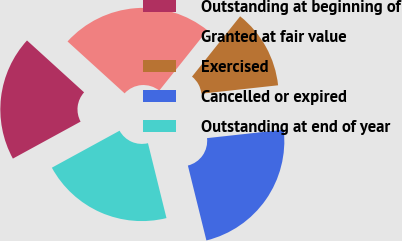Convert chart. <chart><loc_0><loc_0><loc_500><loc_500><pie_chart><fcel>Outstanding at beginning of<fcel>Granted at fair value<fcel>Exercised<fcel>Cancelled or expired<fcel>Outstanding at end of year<nl><fcel>19.7%<fcel>23.98%<fcel>12.54%<fcel>22.88%<fcel>20.9%<nl></chart> 